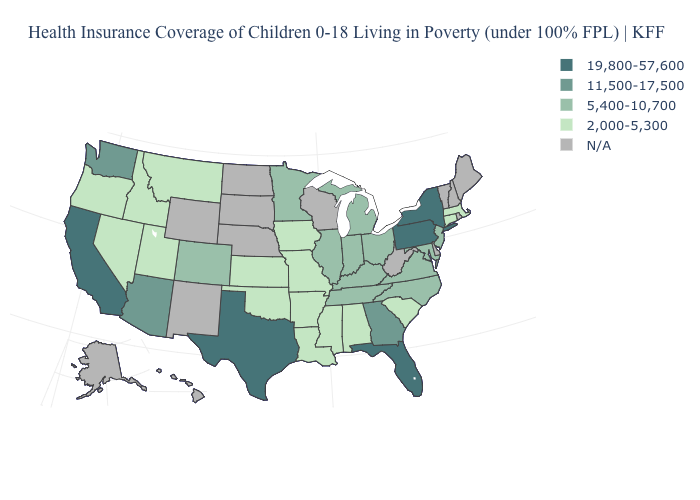What is the value of Oklahoma?
Short answer required. 2,000-5,300. Is the legend a continuous bar?
Be succinct. No. What is the value of Indiana?
Be succinct. 5,400-10,700. Among the states that border Delaware , which have the lowest value?
Give a very brief answer. Maryland, New Jersey. Name the states that have a value in the range 2,000-5,300?
Be succinct. Alabama, Arkansas, Connecticut, Idaho, Iowa, Kansas, Louisiana, Massachusetts, Mississippi, Missouri, Montana, Nevada, Oklahoma, Oregon, South Carolina, Utah. What is the highest value in the Northeast ?
Concise answer only. 19,800-57,600. Does Illinois have the highest value in the USA?
Give a very brief answer. No. Name the states that have a value in the range 5,400-10,700?
Keep it brief. Colorado, Illinois, Indiana, Kentucky, Maryland, Michigan, Minnesota, New Jersey, North Carolina, Ohio, Tennessee, Virginia. Name the states that have a value in the range 2,000-5,300?
Quick response, please. Alabama, Arkansas, Connecticut, Idaho, Iowa, Kansas, Louisiana, Massachusetts, Mississippi, Missouri, Montana, Nevada, Oklahoma, Oregon, South Carolina, Utah. Which states have the lowest value in the West?
Answer briefly. Idaho, Montana, Nevada, Oregon, Utah. How many symbols are there in the legend?
Answer briefly. 5. Is the legend a continuous bar?
Keep it brief. No. Name the states that have a value in the range 11,500-17,500?
Answer briefly. Arizona, Georgia, Washington. Among the states that border Illinois , which have the lowest value?
Quick response, please. Iowa, Missouri. What is the value of North Dakota?
Concise answer only. N/A. 